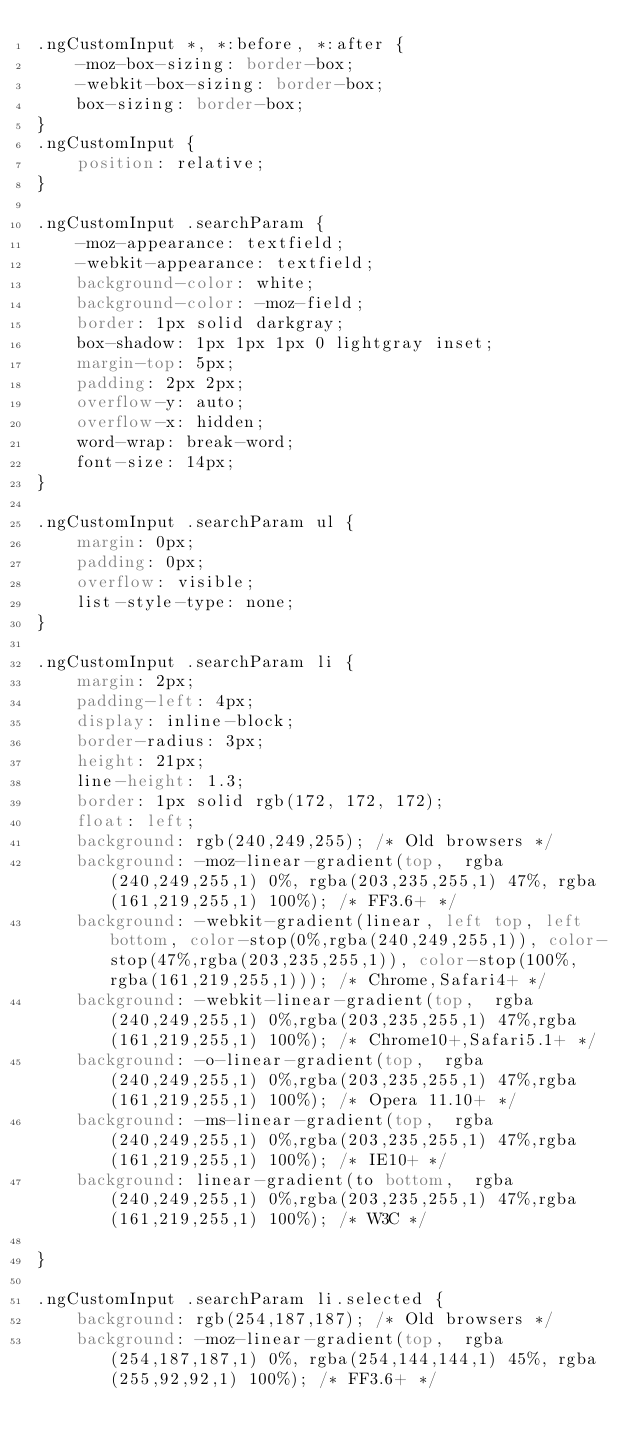<code> <loc_0><loc_0><loc_500><loc_500><_CSS_>.ngCustomInput *, *:before, *:after {
    -moz-box-sizing: border-box;
    -webkit-box-sizing: border-box;
    box-sizing: border-box;
}
.ngCustomInput {
    position: relative;
}

.ngCustomInput .searchParam {
    -moz-appearance: textfield;
    -webkit-appearance: textfield;
    background-color: white;
    background-color: -moz-field;
    border: 1px solid darkgray;
    box-shadow: 1px 1px 1px 0 lightgray inset;
    margin-top: 5px;
    padding: 2px 2px;
    overflow-y: auto;
    overflow-x: hidden;
    word-wrap: break-word;
    font-size: 14px;
}

.ngCustomInput .searchParam ul {
    margin: 0px;
    padding: 0px;
    overflow: visible;
    list-style-type: none;
}

.ngCustomInput .searchParam li {
    margin: 2px;
    padding-left: 4px;
    display: inline-block;
    border-radius: 3px;
    height: 21px;
    line-height: 1.3;
    border: 1px solid rgb(172, 172, 172);
    float: left;
    background: rgb(240,249,255); /* Old browsers */
    background: -moz-linear-gradient(top,  rgba(240,249,255,1) 0%, rgba(203,235,255,1) 47%, rgba(161,219,255,1) 100%); /* FF3.6+ */
    background: -webkit-gradient(linear, left top, left bottom, color-stop(0%,rgba(240,249,255,1)), color-stop(47%,rgba(203,235,255,1)), color-stop(100%,rgba(161,219,255,1))); /* Chrome,Safari4+ */
    background: -webkit-linear-gradient(top,  rgba(240,249,255,1) 0%,rgba(203,235,255,1) 47%,rgba(161,219,255,1) 100%); /* Chrome10+,Safari5.1+ */
    background: -o-linear-gradient(top,  rgba(240,249,255,1) 0%,rgba(203,235,255,1) 47%,rgba(161,219,255,1) 100%); /* Opera 11.10+ */
    background: -ms-linear-gradient(top,  rgba(240,249,255,1) 0%,rgba(203,235,255,1) 47%,rgba(161,219,255,1) 100%); /* IE10+ */
    background: linear-gradient(to bottom,  rgba(240,249,255,1) 0%,rgba(203,235,255,1) 47%,rgba(161,219,255,1) 100%); /* W3C */

}

.ngCustomInput .searchParam li.selected {
    background: rgb(254,187,187); /* Old browsers */
    background: -moz-linear-gradient(top,  rgba(254,187,187,1) 0%, rgba(254,144,144,1) 45%, rgba(255,92,92,1) 100%); /* FF3.6+ */</code> 